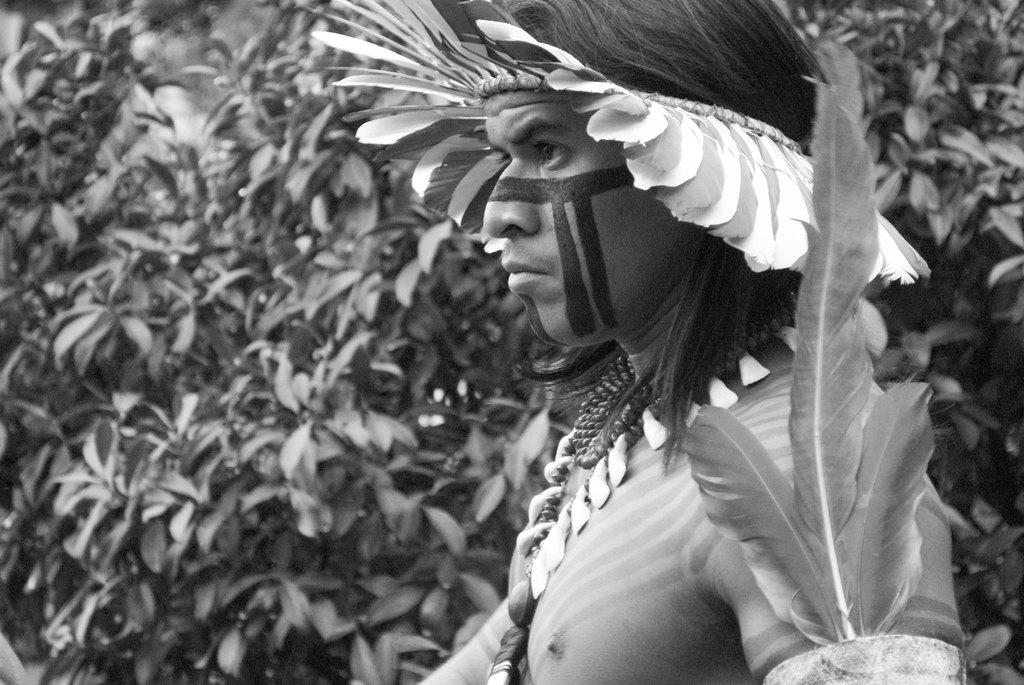What type of vegetation can be seen in the image? There are trees in the image. Can you describe the person in the image? There is a man standing in the front of the image. What type of curtain is hanging in the image? There is no curtain present in the image; it features trees and a man standing in front. How often does the man wash his clothes in the image? There is no information about the man's laundry habits in the image. 